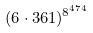Convert formula to latex. <formula><loc_0><loc_0><loc_500><loc_500>( 6 \cdot 3 6 1 ) ^ { 8 ^ { 4 7 4 } }</formula> 